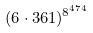Convert formula to latex. <formula><loc_0><loc_0><loc_500><loc_500>( 6 \cdot 3 6 1 ) ^ { 8 ^ { 4 7 4 } }</formula> 